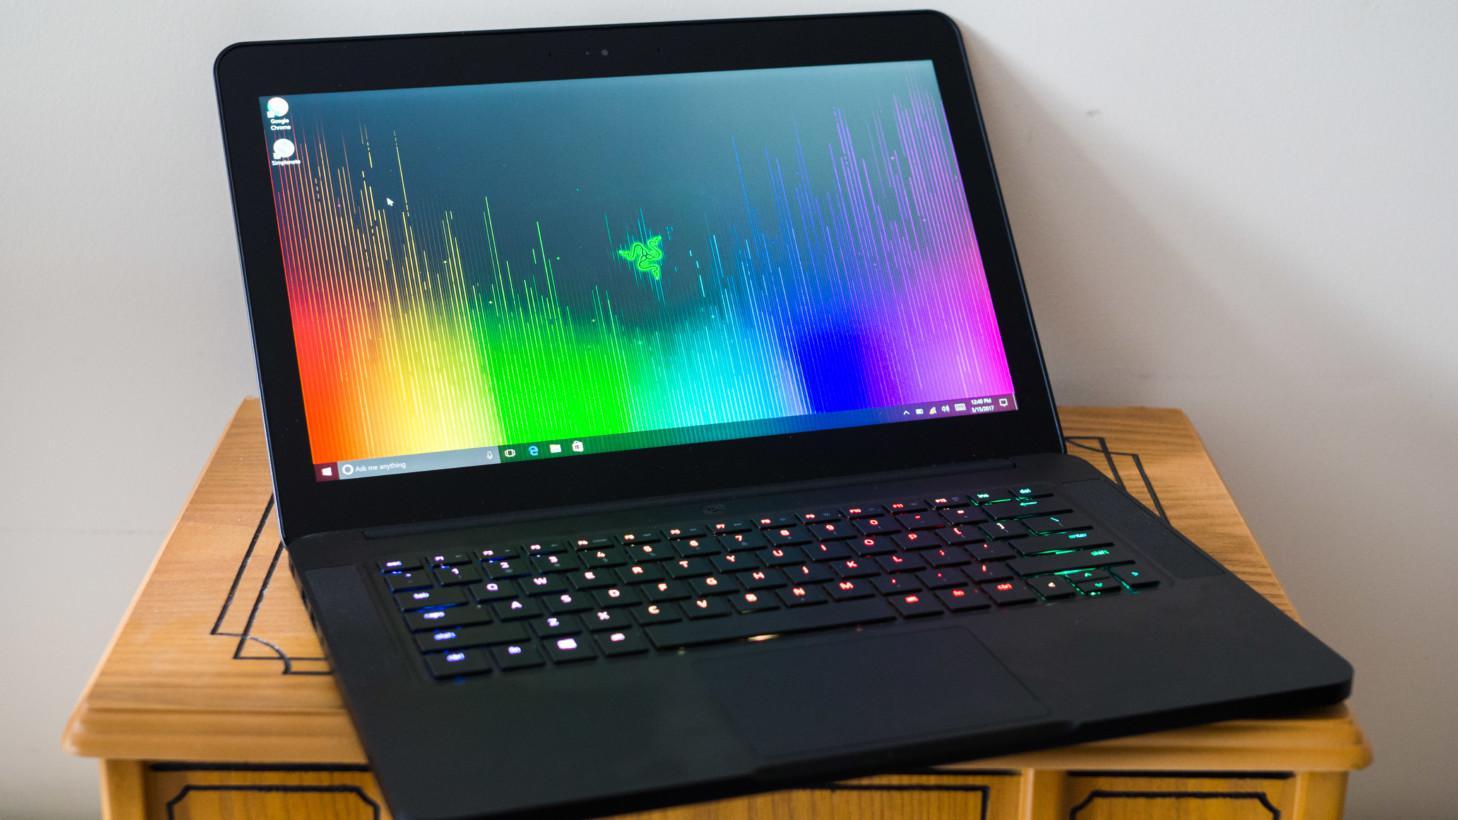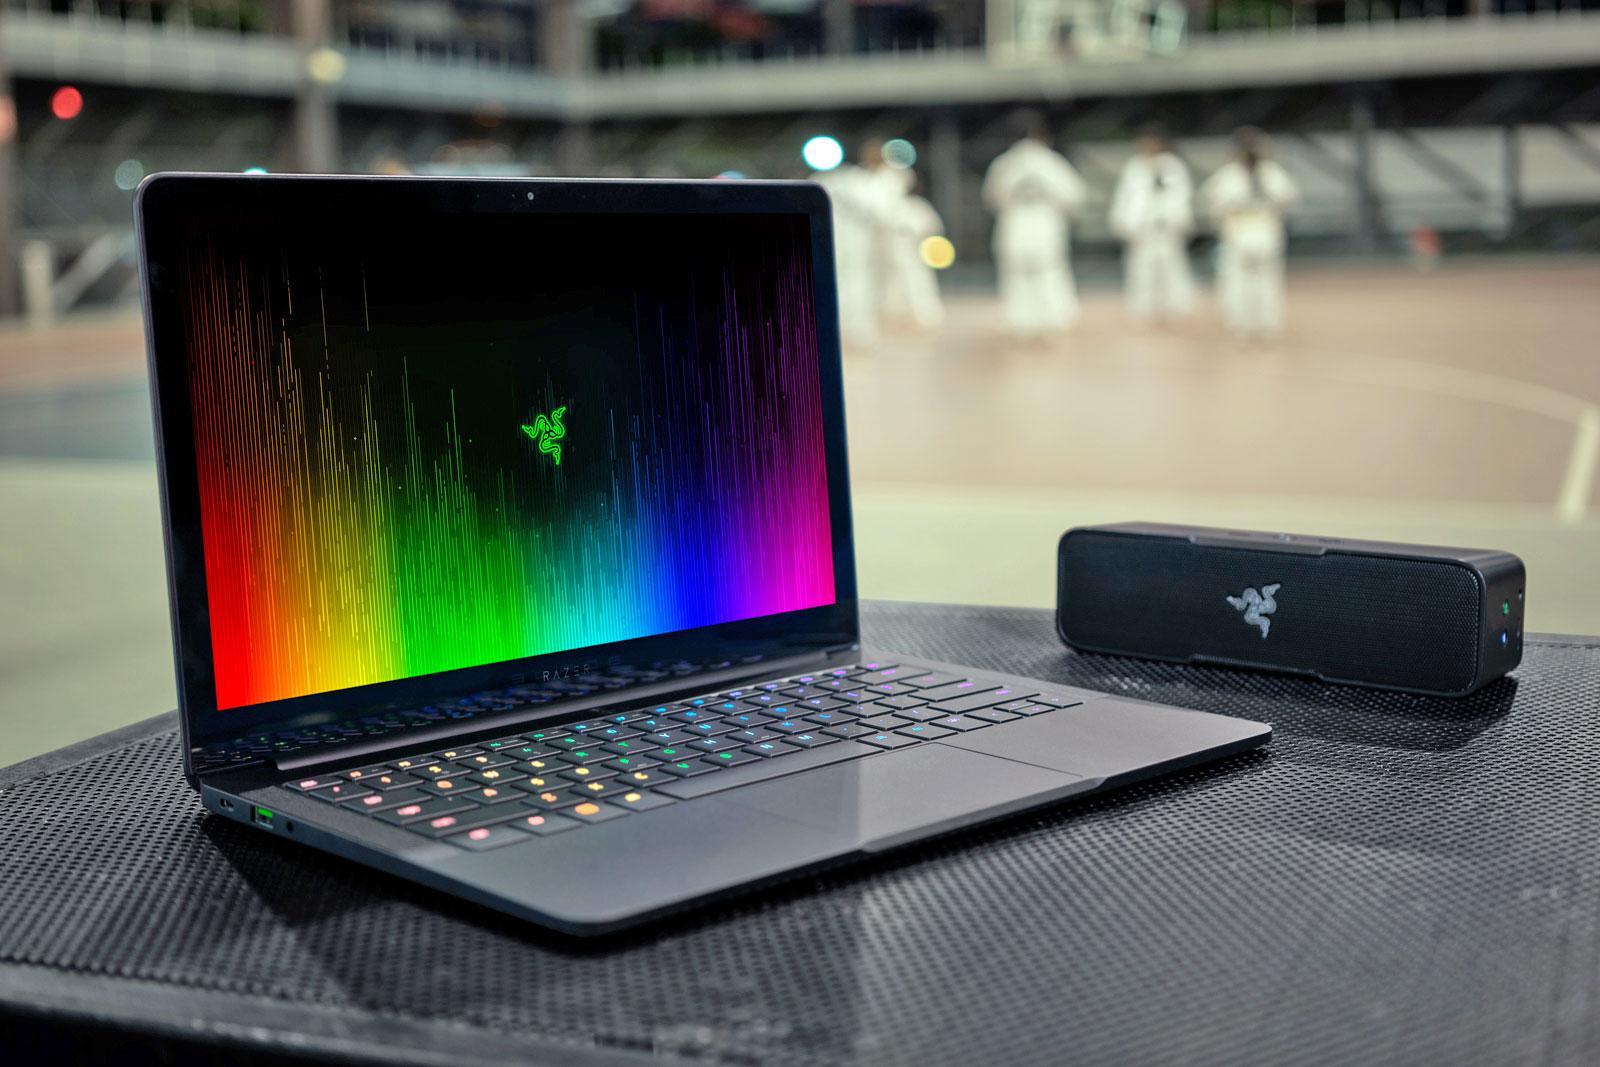The first image is the image on the left, the second image is the image on the right. Analyze the images presented: Is the assertion "The laptop on the right has its start menu open and visible." valid? Answer yes or no. No. 